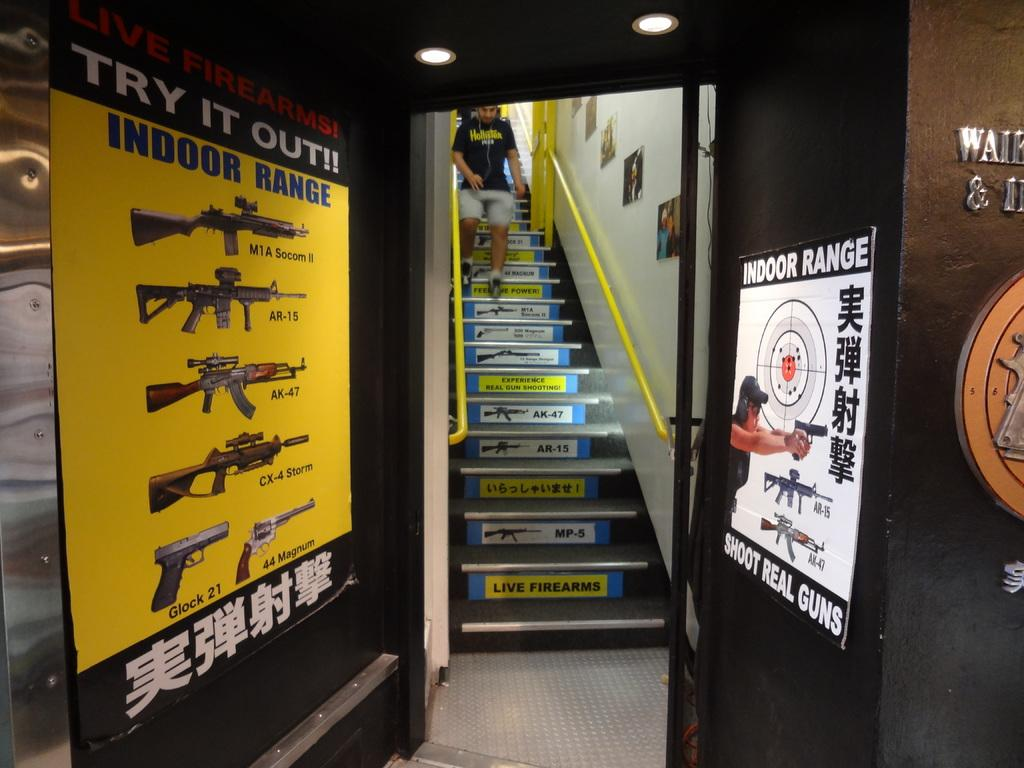<image>
Give a short and clear explanation of the subsequent image. An Indoor Range has posters up that say "Try it Out!!" and "Shoot Real Guns", with a person descending the stairs in the background. 